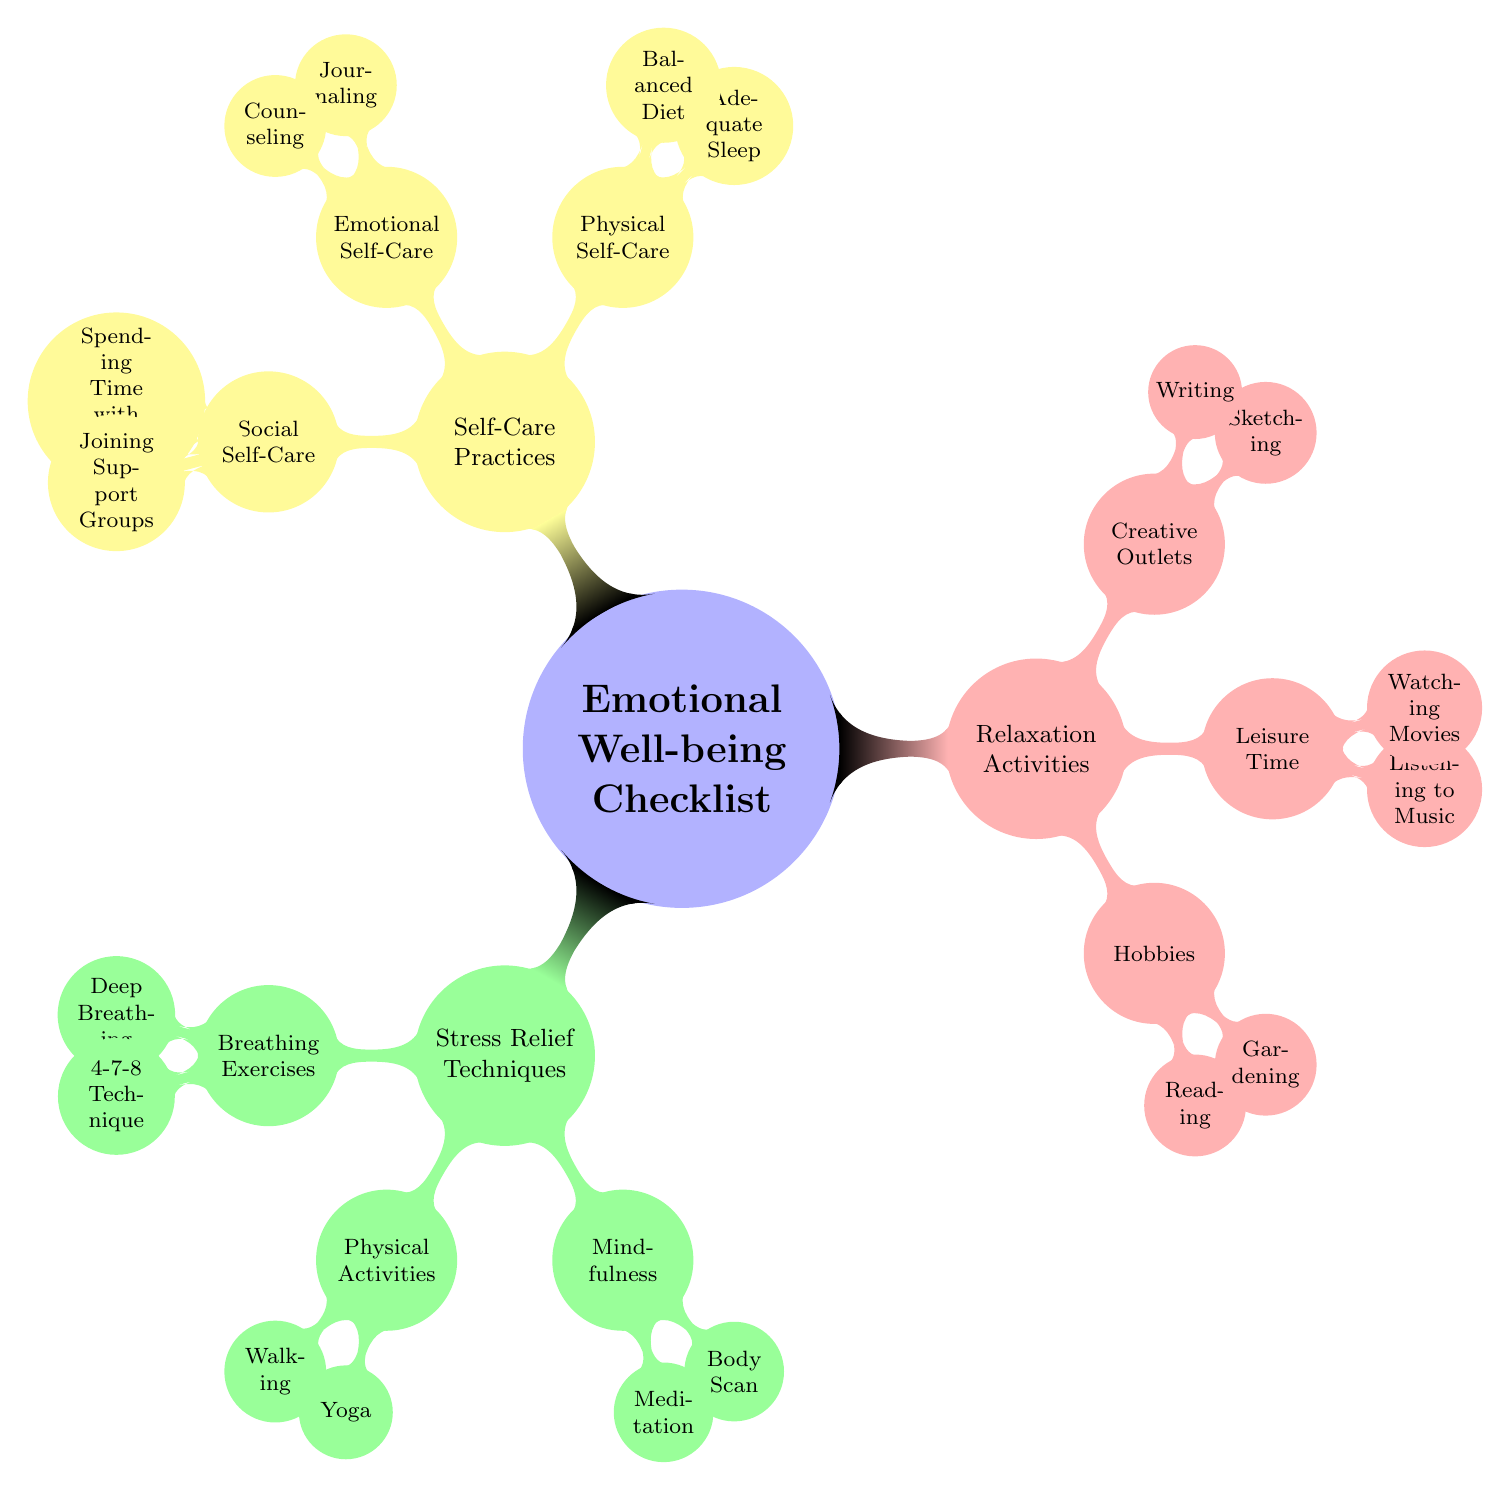What is the central concept represented in the diagram? The central concept is located at the top of the mind map and is labeled "Emotional Well-being Checklist." It represents the overarching theme of the diagram.
Answer: Emotional Well-being Checklist How many main categories does the diagram divide emotional well-being into? By examining the first level of nodes, three main categories can be identified: Stress Relief Techniques, Relaxation Activities, and Self-Care Practices.
Answer: 3 Which stress relief technique involves physical movement? Looking at the "Stress Relief Techniques" category, "Physical Activities" is a child node that directly relates to physical movement.
Answer: Physical Activities Name one example of a self-care practice related to emotional well-being. Under the "Self-Care Practices" category, the examples listed include both "Journaling" and "Counseling," any of which can be correctly identified.
Answer: Journaling What relaxation activity is related to listening? Within the "Relaxation Activities" category, "Leisure Time" includes "Listening to Music," making it the answer related to listening.
Answer: Listening to Music What type of self-care involves interaction with others? By looking under "Self-Care Practices," the “Social Self-Care” category is identified, which includes activities that involve interaction with others.
Answer: Social Self-Care Which breathing technique is specifically mentioned as a stress relief method? Within the "Stress Relief Techniques" under "Breathing Exercises," the "4-7-8 Technique" is specifically mentioned as one of the techniques.
Answer: 4-7-8 Technique How many hobbies related to relaxation are presented in the diagram? In the "Relaxation Activities" section under "Hobbies," there are two listed: "Reading" and "Gardening." Adding them gives a total of 2 hobbies.
Answer: 2 What is the relationship between mindfulness and stress relief? "Mindfulness" is a child node under "Stress Relief Techniques," indicating it is one of the methods contributing to stress relief.
Answer: Mindfulness 